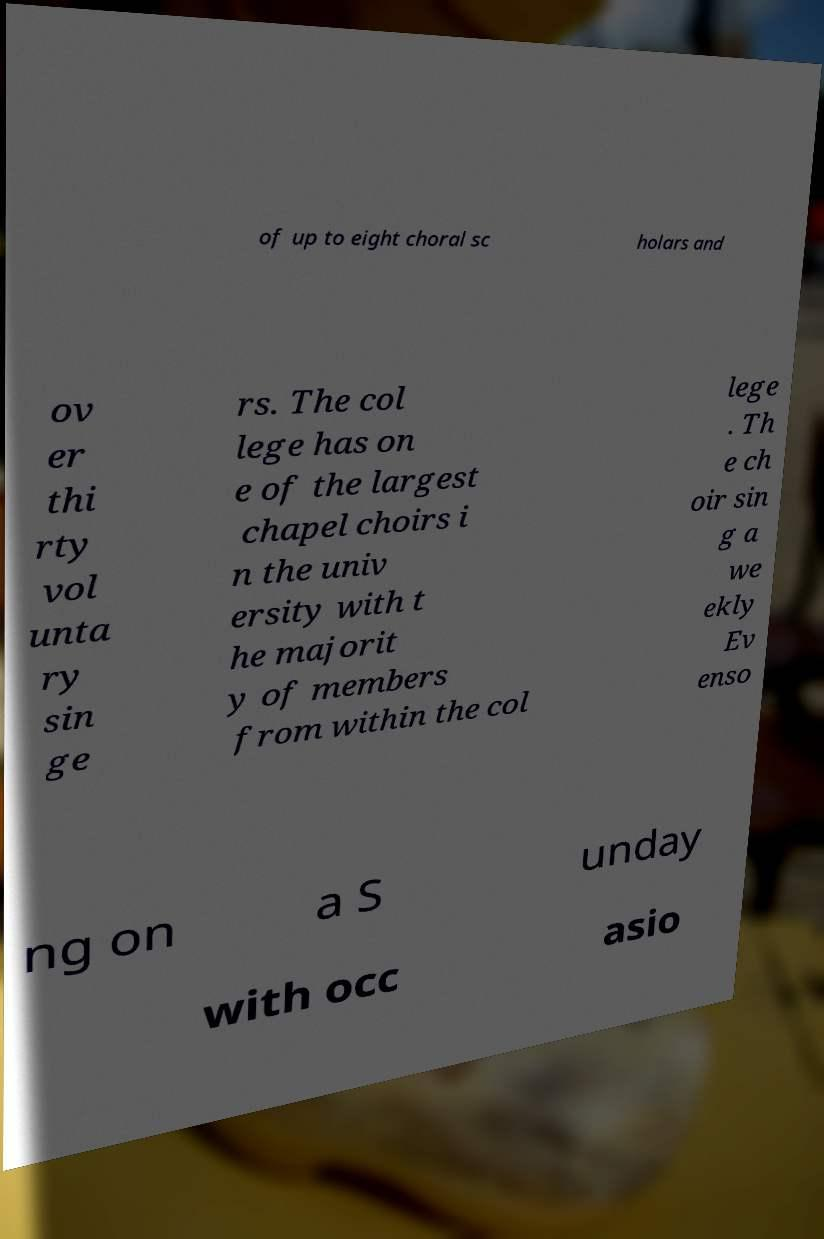For documentation purposes, I need the text within this image transcribed. Could you provide that? of up to eight choral sc holars and ov er thi rty vol unta ry sin ge rs. The col lege has on e of the largest chapel choirs i n the univ ersity with t he majorit y of members from within the col lege . Th e ch oir sin g a we ekly Ev enso ng on a S unday with occ asio 